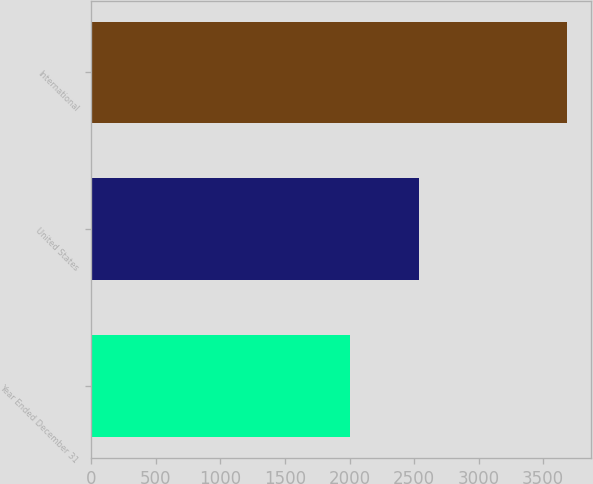Convert chart. <chart><loc_0><loc_0><loc_500><loc_500><bar_chart><fcel>Year Ended December 31<fcel>United States<fcel>International<nl><fcel>2004<fcel>2535<fcel>3687<nl></chart> 